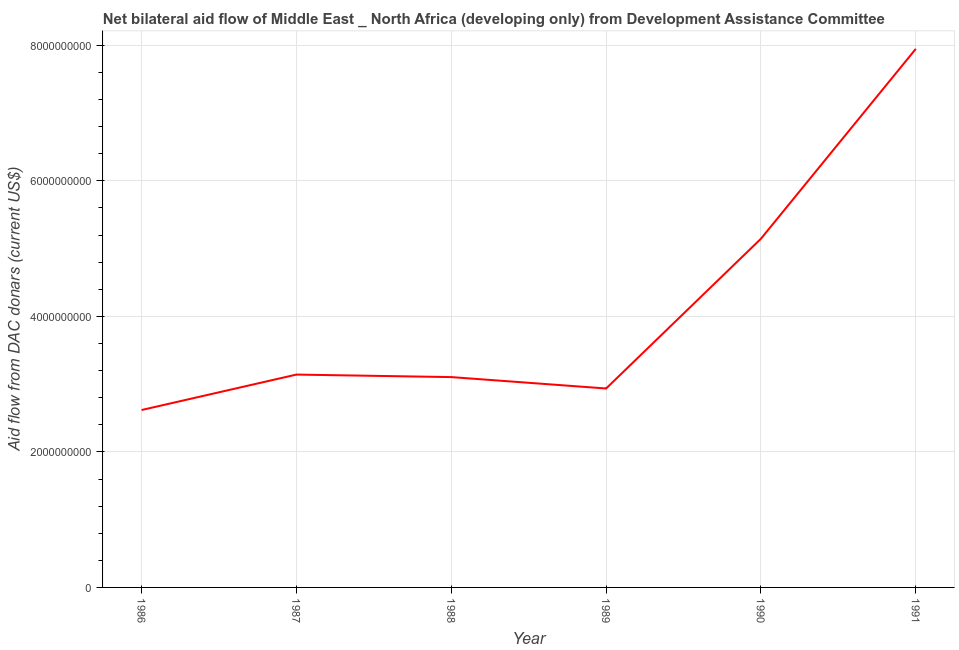What is the net bilateral aid flows from dac donors in 1990?
Your answer should be compact. 5.15e+09. Across all years, what is the maximum net bilateral aid flows from dac donors?
Offer a terse response. 7.95e+09. Across all years, what is the minimum net bilateral aid flows from dac donors?
Provide a short and direct response. 2.62e+09. In which year was the net bilateral aid flows from dac donors maximum?
Give a very brief answer. 1991. In which year was the net bilateral aid flows from dac donors minimum?
Provide a succinct answer. 1986. What is the sum of the net bilateral aid flows from dac donors?
Make the answer very short. 2.49e+1. What is the difference between the net bilateral aid flows from dac donors in 1986 and 1990?
Keep it short and to the point. -2.53e+09. What is the average net bilateral aid flows from dac donors per year?
Provide a short and direct response. 4.15e+09. What is the median net bilateral aid flows from dac donors?
Keep it short and to the point. 3.12e+09. What is the ratio of the net bilateral aid flows from dac donors in 1987 to that in 1990?
Provide a succinct answer. 0.61. Is the net bilateral aid flows from dac donors in 1988 less than that in 1989?
Offer a terse response. No. Is the difference between the net bilateral aid flows from dac donors in 1988 and 1990 greater than the difference between any two years?
Provide a succinct answer. No. What is the difference between the highest and the second highest net bilateral aid flows from dac donors?
Your response must be concise. 2.80e+09. Is the sum of the net bilateral aid flows from dac donors in 1989 and 1990 greater than the maximum net bilateral aid flows from dac donors across all years?
Your response must be concise. Yes. What is the difference between the highest and the lowest net bilateral aid flows from dac donors?
Your response must be concise. 5.33e+09. In how many years, is the net bilateral aid flows from dac donors greater than the average net bilateral aid flows from dac donors taken over all years?
Make the answer very short. 2. How many years are there in the graph?
Offer a terse response. 6. Are the values on the major ticks of Y-axis written in scientific E-notation?
Your response must be concise. No. Does the graph contain any zero values?
Make the answer very short. No. Does the graph contain grids?
Make the answer very short. Yes. What is the title of the graph?
Your answer should be very brief. Net bilateral aid flow of Middle East _ North Africa (developing only) from Development Assistance Committee. What is the label or title of the X-axis?
Your answer should be compact. Year. What is the label or title of the Y-axis?
Make the answer very short. Aid flow from DAC donars (current US$). What is the Aid flow from DAC donars (current US$) in 1986?
Keep it short and to the point. 2.62e+09. What is the Aid flow from DAC donars (current US$) of 1987?
Offer a terse response. 3.14e+09. What is the Aid flow from DAC donars (current US$) of 1988?
Make the answer very short. 3.10e+09. What is the Aid flow from DAC donars (current US$) of 1989?
Provide a succinct answer. 2.94e+09. What is the Aid flow from DAC donars (current US$) of 1990?
Your response must be concise. 5.15e+09. What is the Aid flow from DAC donars (current US$) of 1991?
Keep it short and to the point. 7.95e+09. What is the difference between the Aid flow from DAC donars (current US$) in 1986 and 1987?
Your response must be concise. -5.23e+08. What is the difference between the Aid flow from DAC donars (current US$) in 1986 and 1988?
Your response must be concise. -4.86e+08. What is the difference between the Aid flow from DAC donars (current US$) in 1986 and 1989?
Your answer should be very brief. -3.18e+08. What is the difference between the Aid flow from DAC donars (current US$) in 1986 and 1990?
Your answer should be very brief. -2.53e+09. What is the difference between the Aid flow from DAC donars (current US$) in 1986 and 1991?
Your response must be concise. -5.33e+09. What is the difference between the Aid flow from DAC donars (current US$) in 1987 and 1988?
Your answer should be very brief. 3.72e+07. What is the difference between the Aid flow from DAC donars (current US$) in 1987 and 1989?
Provide a short and direct response. 2.05e+08. What is the difference between the Aid flow from DAC donars (current US$) in 1987 and 1990?
Your answer should be compact. -2.00e+09. What is the difference between the Aid flow from DAC donars (current US$) in 1987 and 1991?
Offer a very short reply. -4.81e+09. What is the difference between the Aid flow from DAC donars (current US$) in 1988 and 1989?
Give a very brief answer. 1.68e+08. What is the difference between the Aid flow from DAC donars (current US$) in 1988 and 1990?
Give a very brief answer. -2.04e+09. What is the difference between the Aid flow from DAC donars (current US$) in 1988 and 1991?
Make the answer very short. -4.84e+09. What is the difference between the Aid flow from DAC donars (current US$) in 1989 and 1990?
Keep it short and to the point. -2.21e+09. What is the difference between the Aid flow from DAC donars (current US$) in 1989 and 1991?
Your response must be concise. -5.01e+09. What is the difference between the Aid flow from DAC donars (current US$) in 1990 and 1991?
Keep it short and to the point. -2.80e+09. What is the ratio of the Aid flow from DAC donars (current US$) in 1986 to that in 1987?
Your answer should be compact. 0.83. What is the ratio of the Aid flow from DAC donars (current US$) in 1986 to that in 1988?
Your answer should be compact. 0.84. What is the ratio of the Aid flow from DAC donars (current US$) in 1986 to that in 1989?
Ensure brevity in your answer.  0.89. What is the ratio of the Aid flow from DAC donars (current US$) in 1986 to that in 1990?
Provide a succinct answer. 0.51. What is the ratio of the Aid flow from DAC donars (current US$) in 1986 to that in 1991?
Give a very brief answer. 0.33. What is the ratio of the Aid flow from DAC donars (current US$) in 1987 to that in 1988?
Give a very brief answer. 1.01. What is the ratio of the Aid flow from DAC donars (current US$) in 1987 to that in 1989?
Make the answer very short. 1.07. What is the ratio of the Aid flow from DAC donars (current US$) in 1987 to that in 1990?
Provide a short and direct response. 0.61. What is the ratio of the Aid flow from DAC donars (current US$) in 1987 to that in 1991?
Keep it short and to the point. 0.4. What is the ratio of the Aid flow from DAC donars (current US$) in 1988 to that in 1989?
Your response must be concise. 1.06. What is the ratio of the Aid flow from DAC donars (current US$) in 1988 to that in 1990?
Your answer should be compact. 0.6. What is the ratio of the Aid flow from DAC donars (current US$) in 1988 to that in 1991?
Offer a very short reply. 0.39. What is the ratio of the Aid flow from DAC donars (current US$) in 1989 to that in 1990?
Offer a terse response. 0.57. What is the ratio of the Aid flow from DAC donars (current US$) in 1989 to that in 1991?
Offer a very short reply. 0.37. What is the ratio of the Aid flow from DAC donars (current US$) in 1990 to that in 1991?
Offer a very short reply. 0.65. 